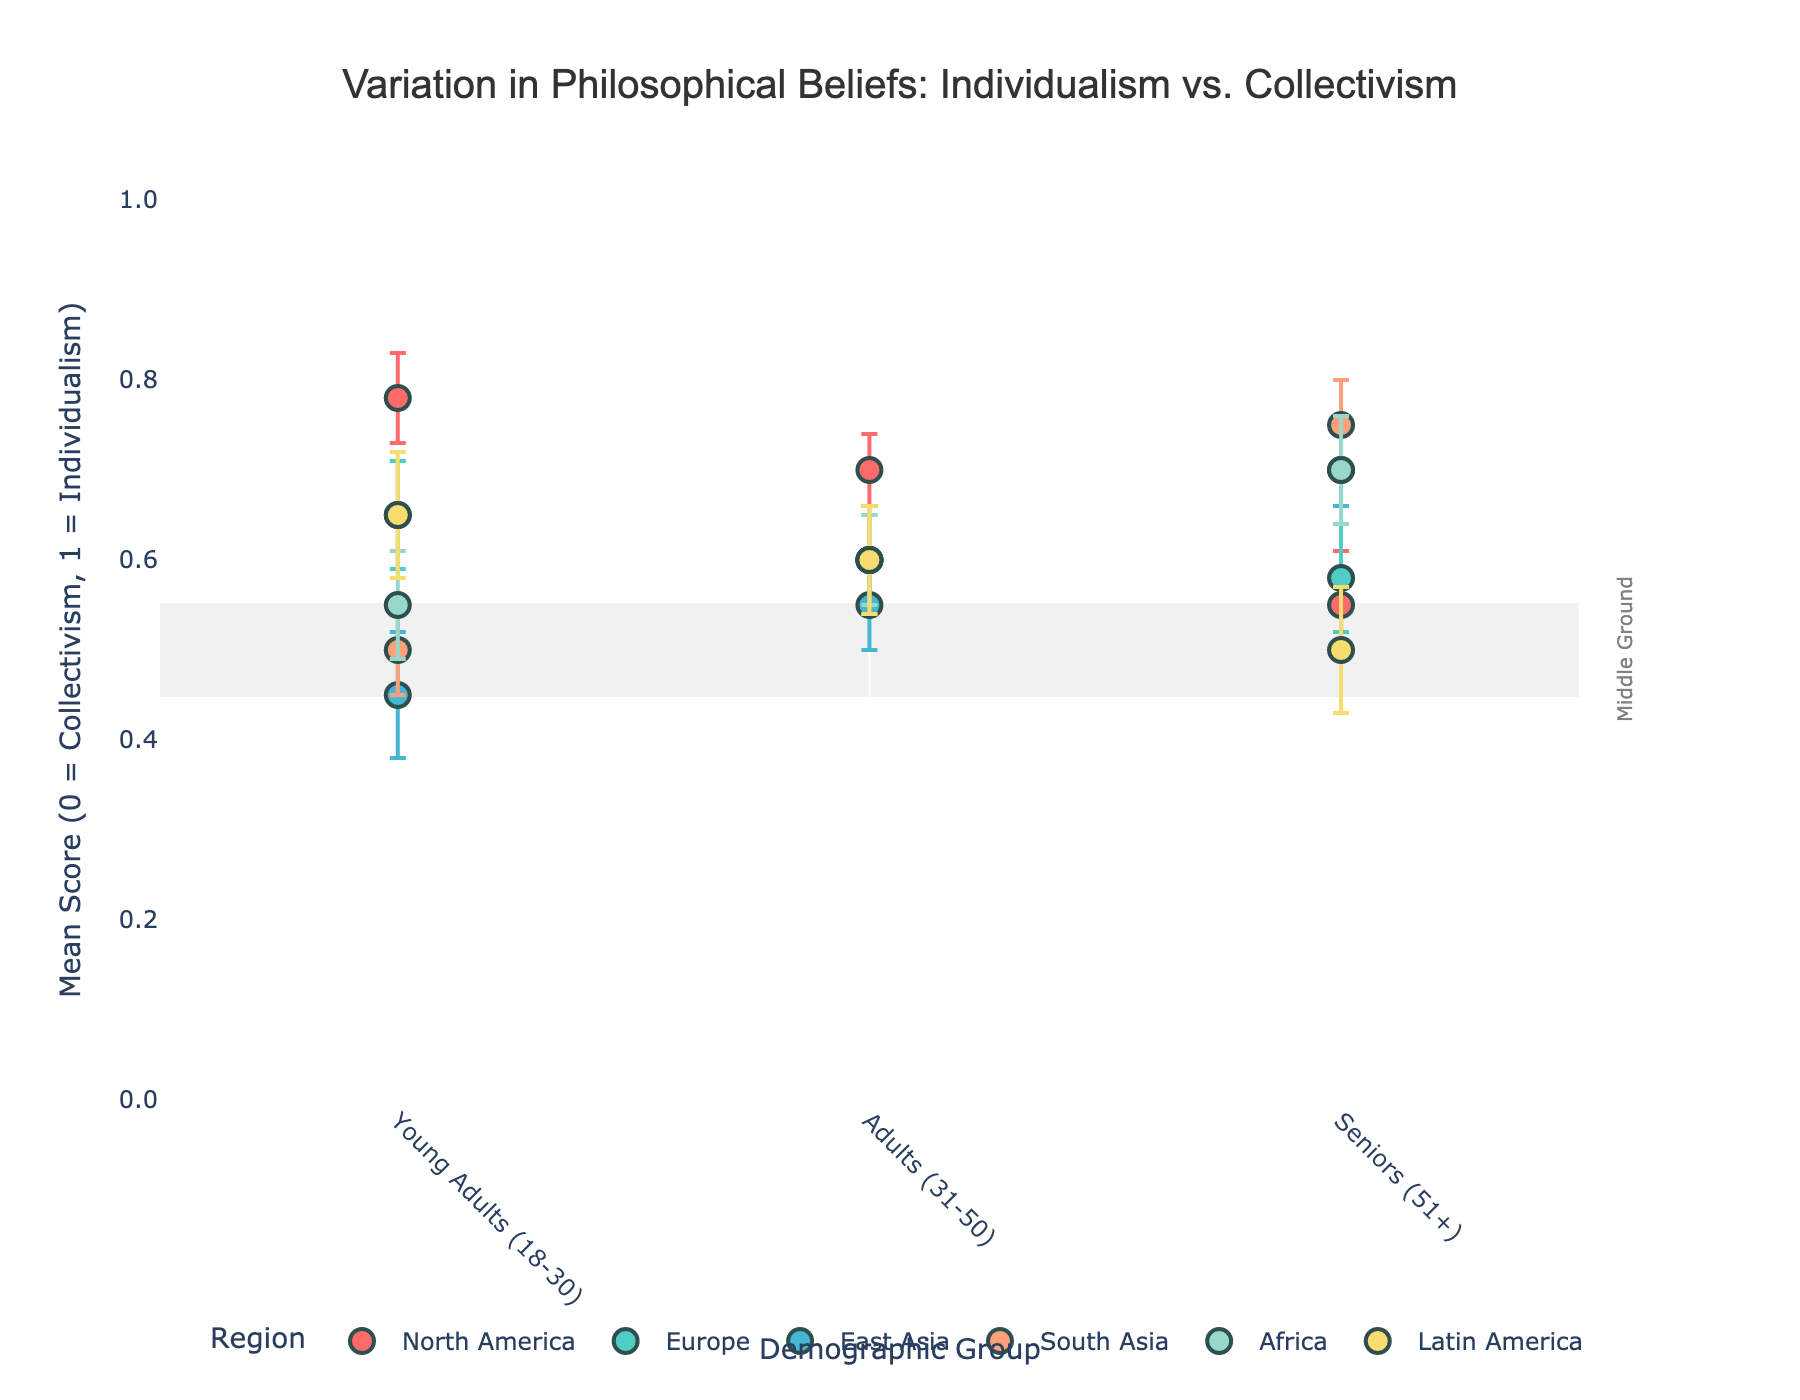What region has the highest mean score for young adults (18-30)? First, find the data points for young adults in each region. North America has a mean of 0.78, Europe has 0.65, East Asia has 0.45, South Asia has 0.50, Africa has 0.55, and Latin America has 0.65. The highest mean is 0.78 in North America.
Answer: North America Which demographic group in East Asia has the highest mean score? Look at the three demographic groups in East Asia: Young Adults (0.45), Adults (0.55), and Seniors (0.70). The highest mean score is 0.70 for Seniors.
Answer: Seniors (51+) How does the mean score for adults (31-50) in Africa compare to adults in South Asia? The mean score for adults in Africa is 0.60, while in South Asia it is also 0.60. Since both values are equal, they have the same mean score.
Answer: Equal Which region's seniors (51+) show a stronger preference for individualism? North America's seniors have a mean score of 0.55, Europe has 0.58, East Asia has 0.70, South Asia has 0.75, Africa has 0.70, Latin America has 0.50. The highest preference for individualism among seniors is in Latin America with a score of 0.50.
Answer: Latin America What is the overall trend in philosophical beliefs from young adults to seniors in Latin America? Look at the mean scores for Latin America: Young Adults (0.65), Adults (0.60), Seniors (0.50). The trend shows a decrease in individualism (or an increase in collectivism) as the age group increases.
Answer: Decrease in individualism Which region has the largest error bar for young adults? Review the error values for young adults in each region: North America (0.05), Europe (0.06), East Asia (0.07), South Asia (0.05), Africa (0.06), Latin America (0.07). The largest error bar is 0.07, which is found in East Asia and Latin America.
Answer: East Asia, Latin America Does the mean score for young adults in North America overlap with the middle ground rectangle? The middle ground rectangle ranges from 0.45 to 0.55 on the y-axis. The mean score for young adults in North America is 0.78, which is outside this range.
Answer: No Which demographic group in Europe is closest to the middle ground? The middle ground ranges from 0.45 to 0.55. The mean scores in Europe are: Young Adults (0.65), Adults (0.60), Seniors (0.58). The closest value is for Seniors with a score of 0.58.
Answer: Seniors (51+) What is the difference in mean score between young adults and seniors in South Asia? The mean score for young adults in South Asia is 0.50, and for seniors, it is 0.75. The difference is 0.75 - 0.50 = 0.25.
Answer: 0.25 